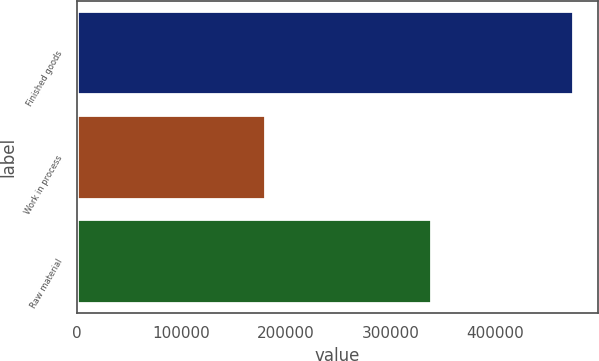<chart> <loc_0><loc_0><loc_500><loc_500><bar_chart><fcel>Finished goods<fcel>Work in process<fcel>Raw material<nl><fcel>474671<fcel>179461<fcel>338884<nl></chart> 